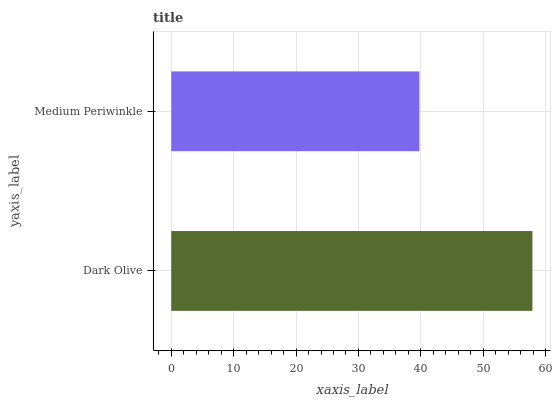Is Medium Periwinkle the minimum?
Answer yes or no. Yes. Is Dark Olive the maximum?
Answer yes or no. Yes. Is Medium Periwinkle the maximum?
Answer yes or no. No. Is Dark Olive greater than Medium Periwinkle?
Answer yes or no. Yes. Is Medium Periwinkle less than Dark Olive?
Answer yes or no. Yes. Is Medium Periwinkle greater than Dark Olive?
Answer yes or no. No. Is Dark Olive less than Medium Periwinkle?
Answer yes or no. No. Is Dark Olive the high median?
Answer yes or no. Yes. Is Medium Periwinkle the low median?
Answer yes or no. Yes. Is Medium Periwinkle the high median?
Answer yes or no. No. Is Dark Olive the low median?
Answer yes or no. No. 